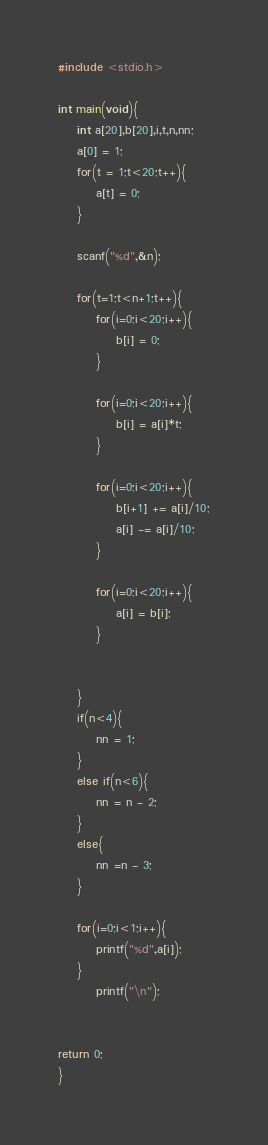Convert code to text. <code><loc_0><loc_0><loc_500><loc_500><_C_>#include <stdio.h>

int main(void){
	int a[20],b[20],i,t,n,nn;
	a[0] = 1;
	for(t = 1;t<20;t++){
		a[t] = 0;
	}

	scanf("%d",&n);

	for(t=1;t<n+1;t++){
		for(i=0;i<20;i++){
			b[i] = 0;
		}

		for(i=0;i<20;i++){
			b[i] = a[i]*t;
		}

		for(i=0;i<20;i++){
			b[i+1] += a[i]/10;
			a[i] -= a[i]/10;
		}

		for(i=0;i<20;i++){
			a[i] = b[i];
		}


	}
	if(n<4){
		nn = 1;
	}
	else if(n<6){
		nn = n - 2;
	}
	else{
		nn =n - 3;
	}

	for(i=0;i<1;i++){
		printf("%d",a[i]);
	}
		printf("\n");


return 0;
}</code> 